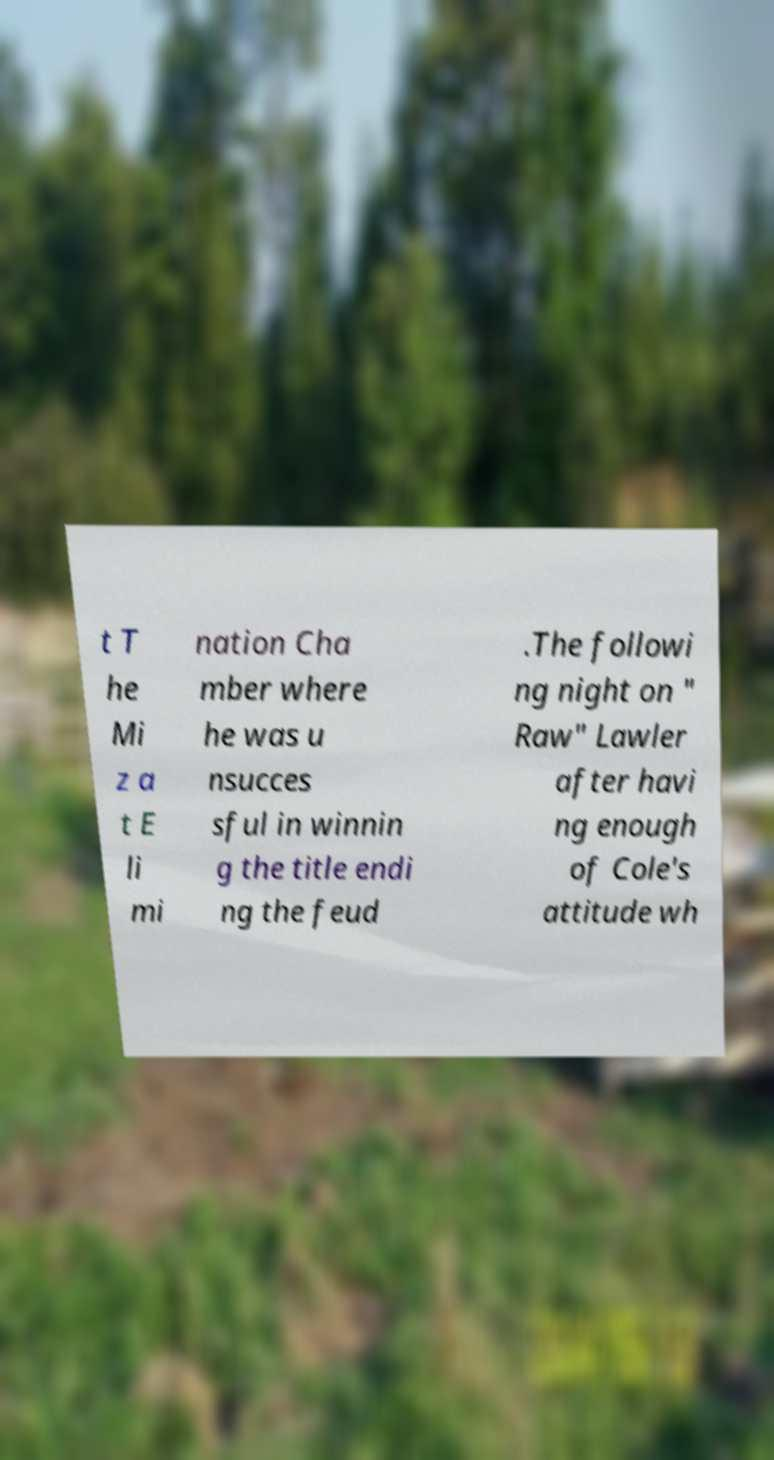Please identify and transcribe the text found in this image. t T he Mi z a t E li mi nation Cha mber where he was u nsucces sful in winnin g the title endi ng the feud .The followi ng night on " Raw" Lawler after havi ng enough of Cole's attitude wh 